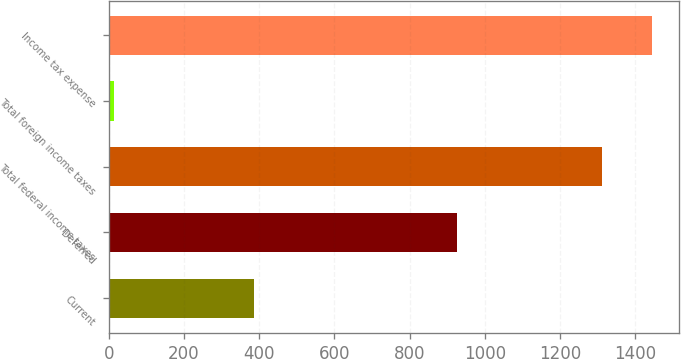<chart> <loc_0><loc_0><loc_500><loc_500><bar_chart><fcel>Current<fcel>Deferred<fcel>Total federal income taxes<fcel>Total foreign income taxes<fcel>Income tax expense<nl><fcel>387<fcel>925<fcel>1312<fcel>15<fcel>1443.2<nl></chart> 